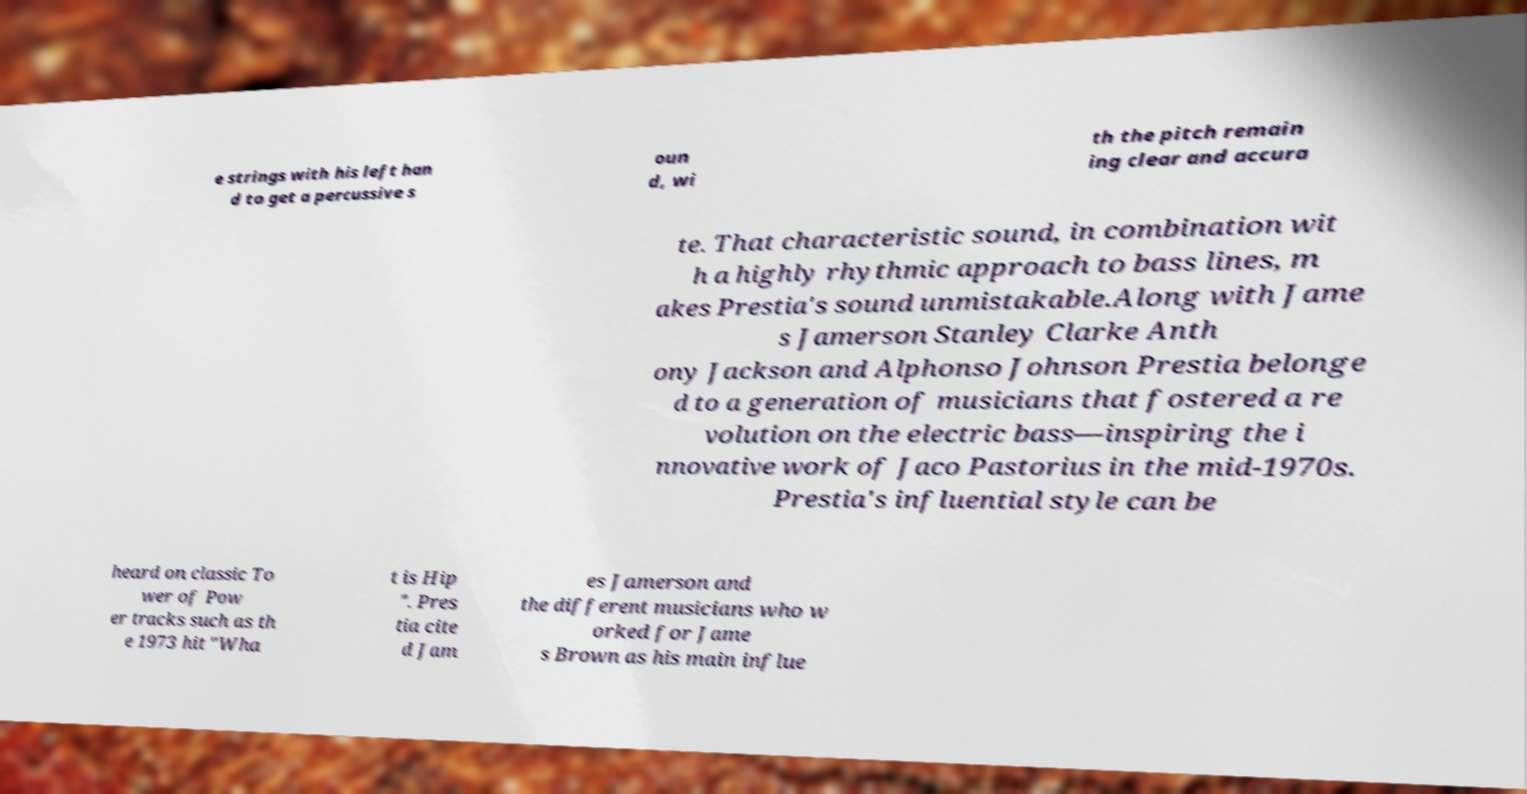There's text embedded in this image that I need extracted. Can you transcribe it verbatim? e strings with his left han d to get a percussive s oun d, wi th the pitch remain ing clear and accura te. That characteristic sound, in combination wit h a highly rhythmic approach to bass lines, m akes Prestia's sound unmistakable.Along with Jame s Jamerson Stanley Clarke Anth ony Jackson and Alphonso Johnson Prestia belonge d to a generation of musicians that fostered a re volution on the electric bass—inspiring the i nnovative work of Jaco Pastorius in the mid-1970s. Prestia's influential style can be heard on classic To wer of Pow er tracks such as th e 1973 hit "Wha t is Hip ". Pres tia cite d Jam es Jamerson and the different musicians who w orked for Jame s Brown as his main influe 